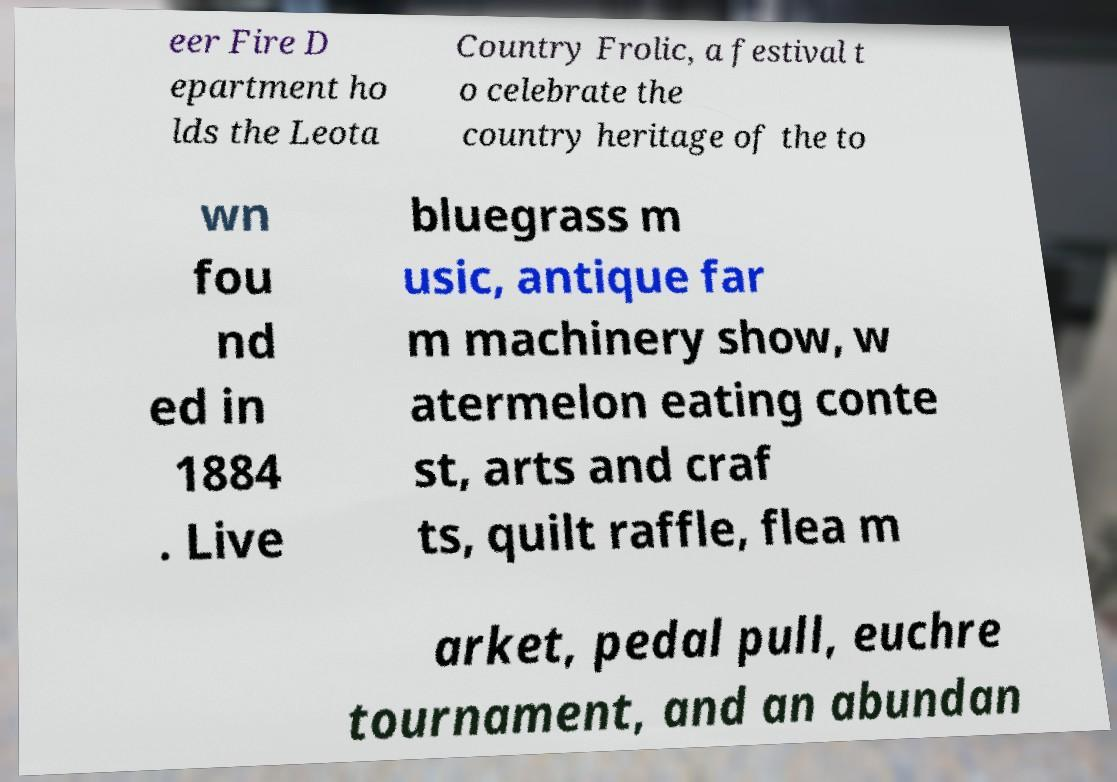Can you read and provide the text displayed in the image?This photo seems to have some interesting text. Can you extract and type it out for me? eer Fire D epartment ho lds the Leota Country Frolic, a festival t o celebrate the country heritage of the to wn fou nd ed in 1884 . Live bluegrass m usic, antique far m machinery show, w atermelon eating conte st, arts and craf ts, quilt raffle, flea m arket, pedal pull, euchre tournament, and an abundan 